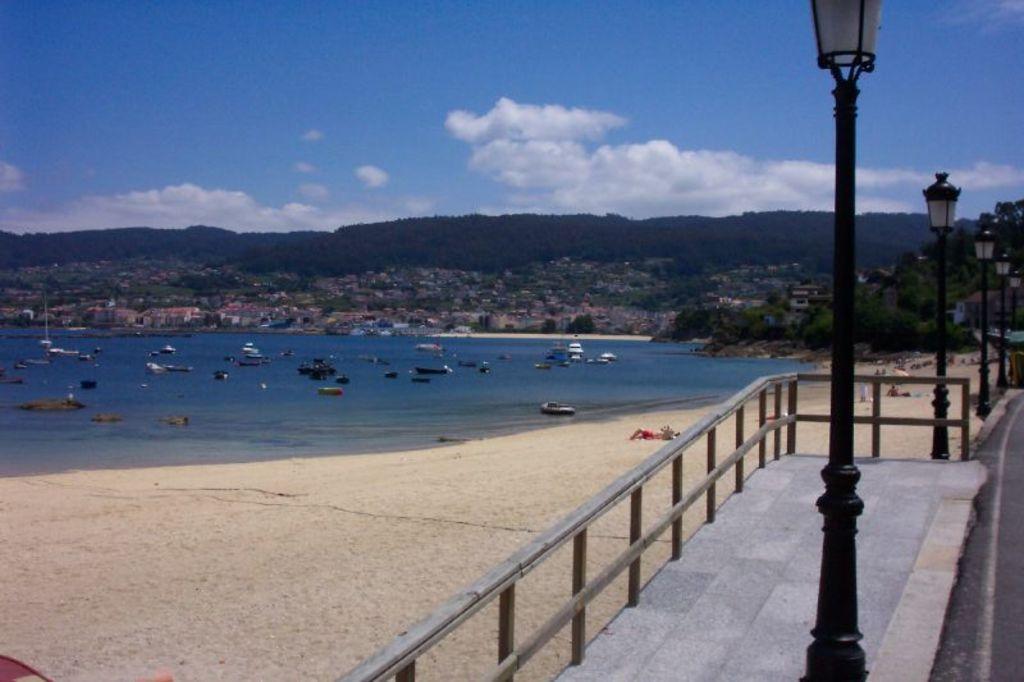How would you summarize this image in a sentence or two? In this picture there is path at the bottom side of the image and there are lamp poles on the right side of the image, there are ships on the water in the center of the image and there are houses and trees in the background area of the image. 